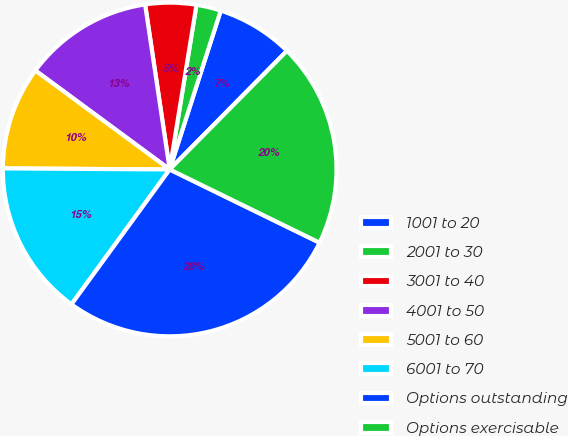Convert chart. <chart><loc_0><loc_0><loc_500><loc_500><pie_chart><fcel>1001 to 20<fcel>2001 to 30<fcel>3001 to 40<fcel>4001 to 50<fcel>5001 to 60<fcel>6001 to 70<fcel>Options outstanding<fcel>Options exercisable<nl><fcel>7.46%<fcel>2.38%<fcel>4.92%<fcel>12.54%<fcel>10.0%<fcel>15.08%<fcel>27.78%<fcel>19.82%<nl></chart> 